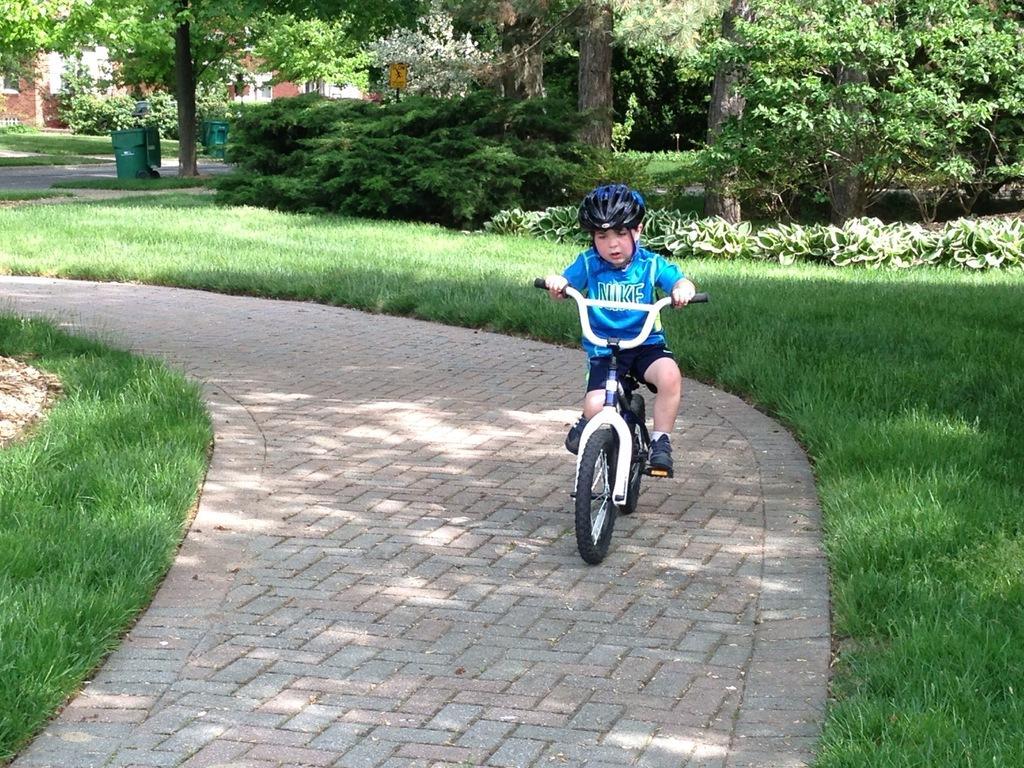Describe this image in one or two sentences. There is a kid riding a bicycle. This is grass and there are plants. Here we can see bins, board, trees, and a house. 